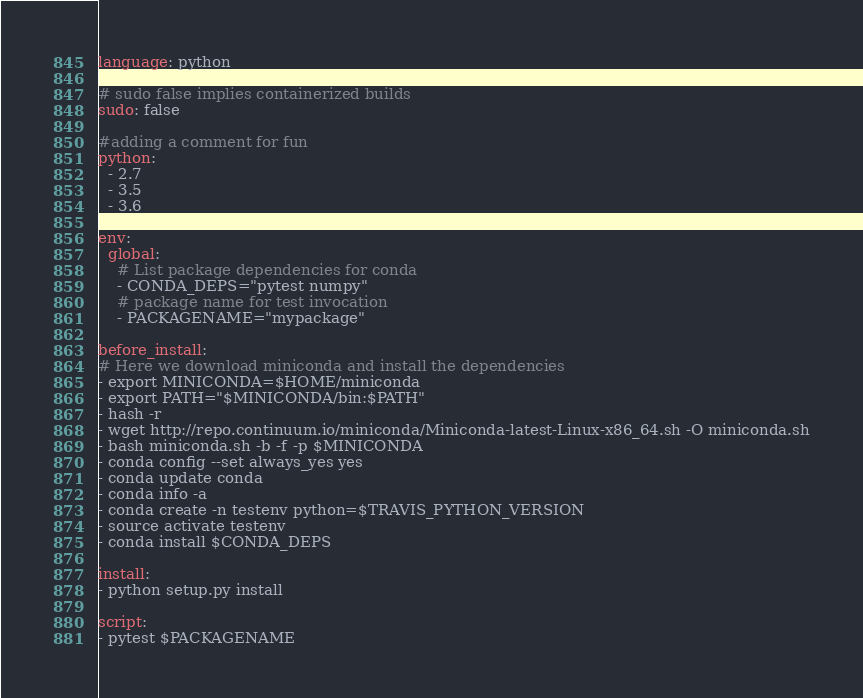<code> <loc_0><loc_0><loc_500><loc_500><_YAML_>language: python

# sudo false implies containerized builds
sudo: false

#adding a comment for fun
python:
  - 2.7
  - 3.5
  - 3.6

env:
  global:
    # List package dependencies for conda
    - CONDA_DEPS="pytest numpy"
    # package name for test invocation
    - PACKAGENAME="mypackage"

before_install:
# Here we download miniconda and install the dependencies
- export MINICONDA=$HOME/miniconda
- export PATH="$MINICONDA/bin:$PATH"
- hash -r
- wget http://repo.continuum.io/miniconda/Miniconda-latest-Linux-x86_64.sh -O miniconda.sh
- bash miniconda.sh -b -f -p $MINICONDA
- conda config --set always_yes yes
- conda update conda
- conda info -a
- conda create -n testenv python=$TRAVIS_PYTHON_VERSION
- source activate testenv
- conda install $CONDA_DEPS

install:
- python setup.py install

script:
- pytest $PACKAGENAME
</code> 